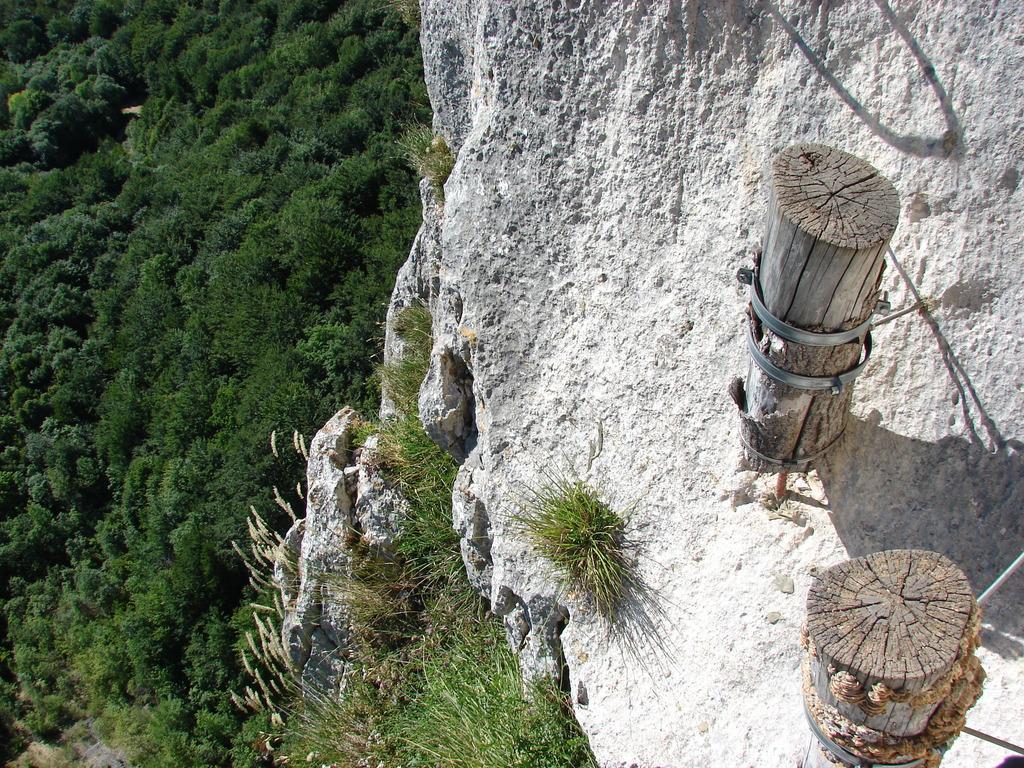In one or two sentences, can you explain what this image depicts? On the right side of the image there are two wooden sticks placed on the rock. On the left side of the image there are trees. 